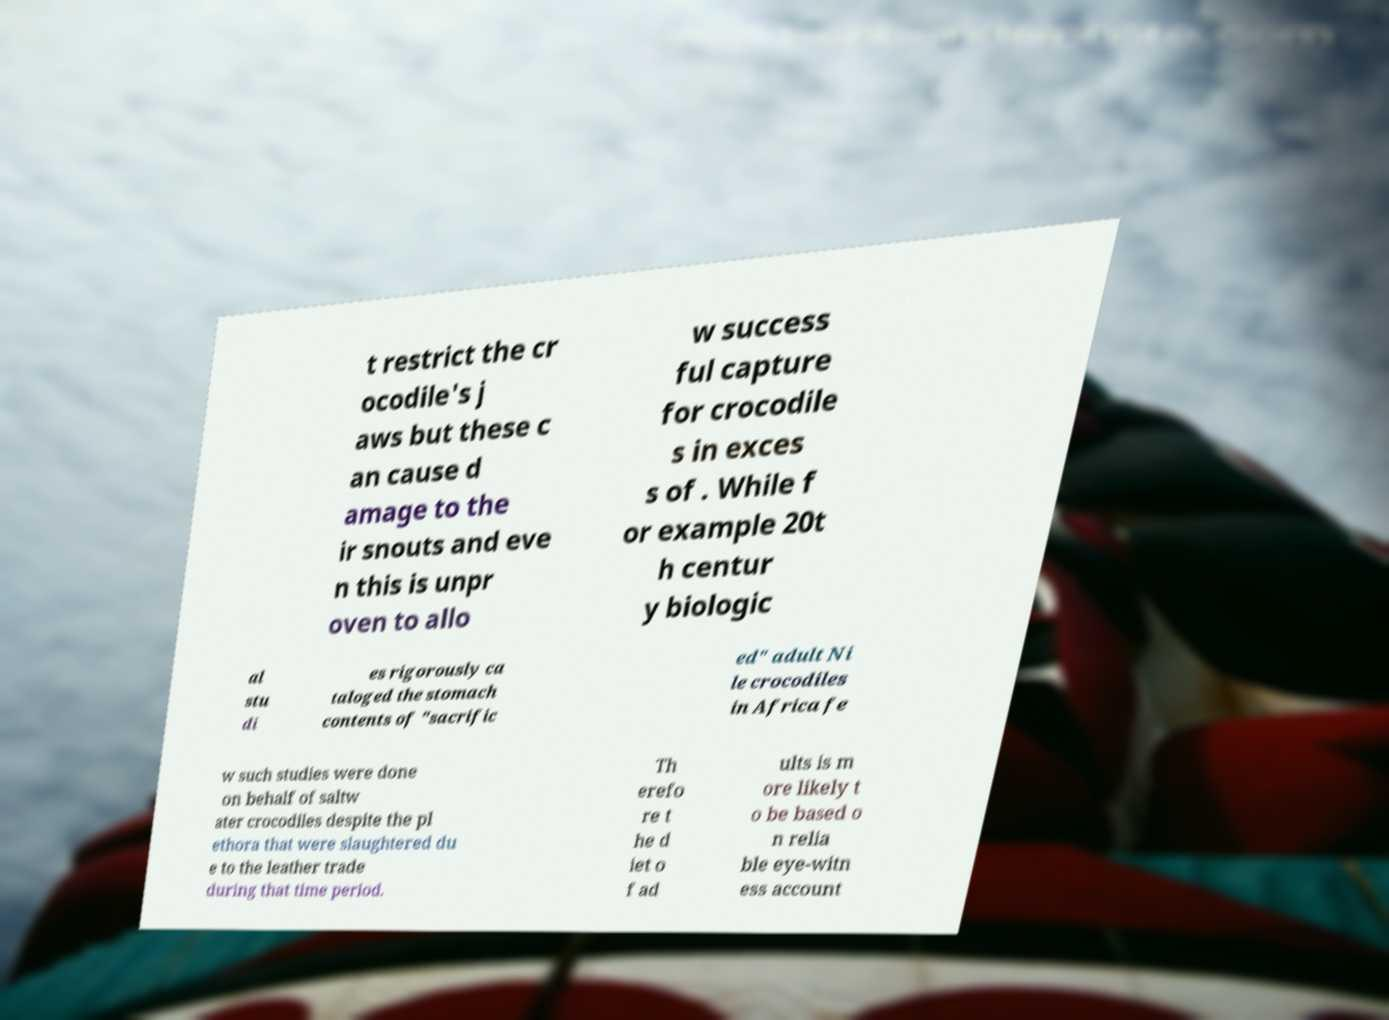Please identify and transcribe the text found in this image. t restrict the cr ocodile's j aws but these c an cause d amage to the ir snouts and eve n this is unpr oven to allo w success ful capture for crocodile s in exces s of . While f or example 20t h centur y biologic al stu di es rigorously ca taloged the stomach contents of "sacrific ed" adult Ni le crocodiles in Africa fe w such studies were done on behalf of saltw ater crocodiles despite the pl ethora that were slaughtered du e to the leather trade during that time period. Th erefo re t he d iet o f ad ults is m ore likely t o be based o n relia ble eye-witn ess account 